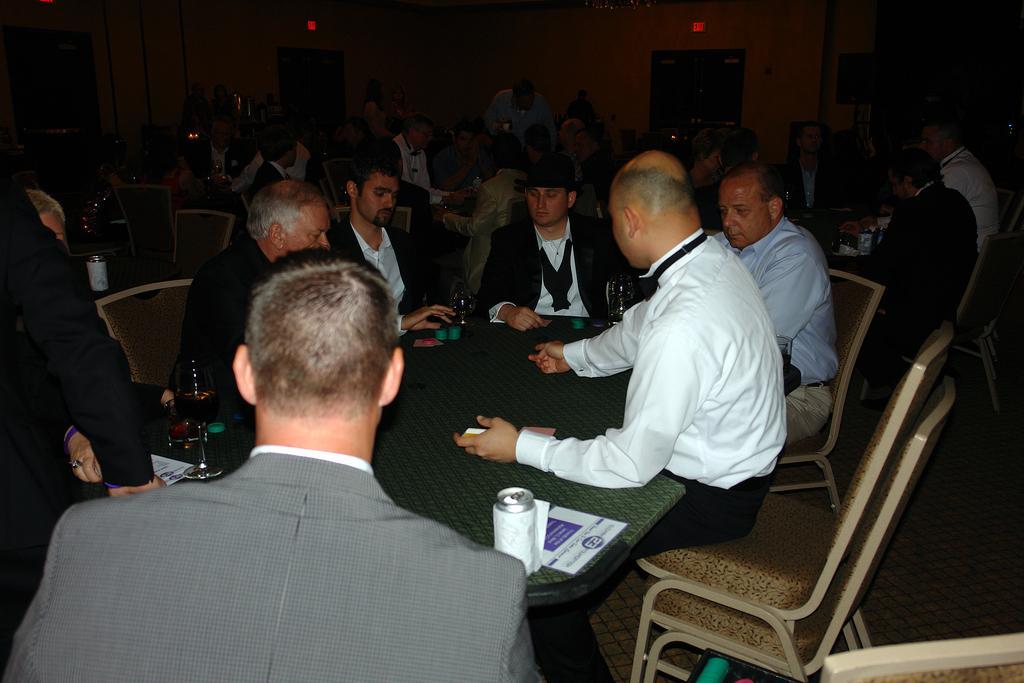Describe this image in one or two sentences. This picture describes about group of people few are seated on the chair and few are standing, in front of them we can find couple of glasses, coins, papers, tins on the table, in the background we can see a wall and couple of lights. 